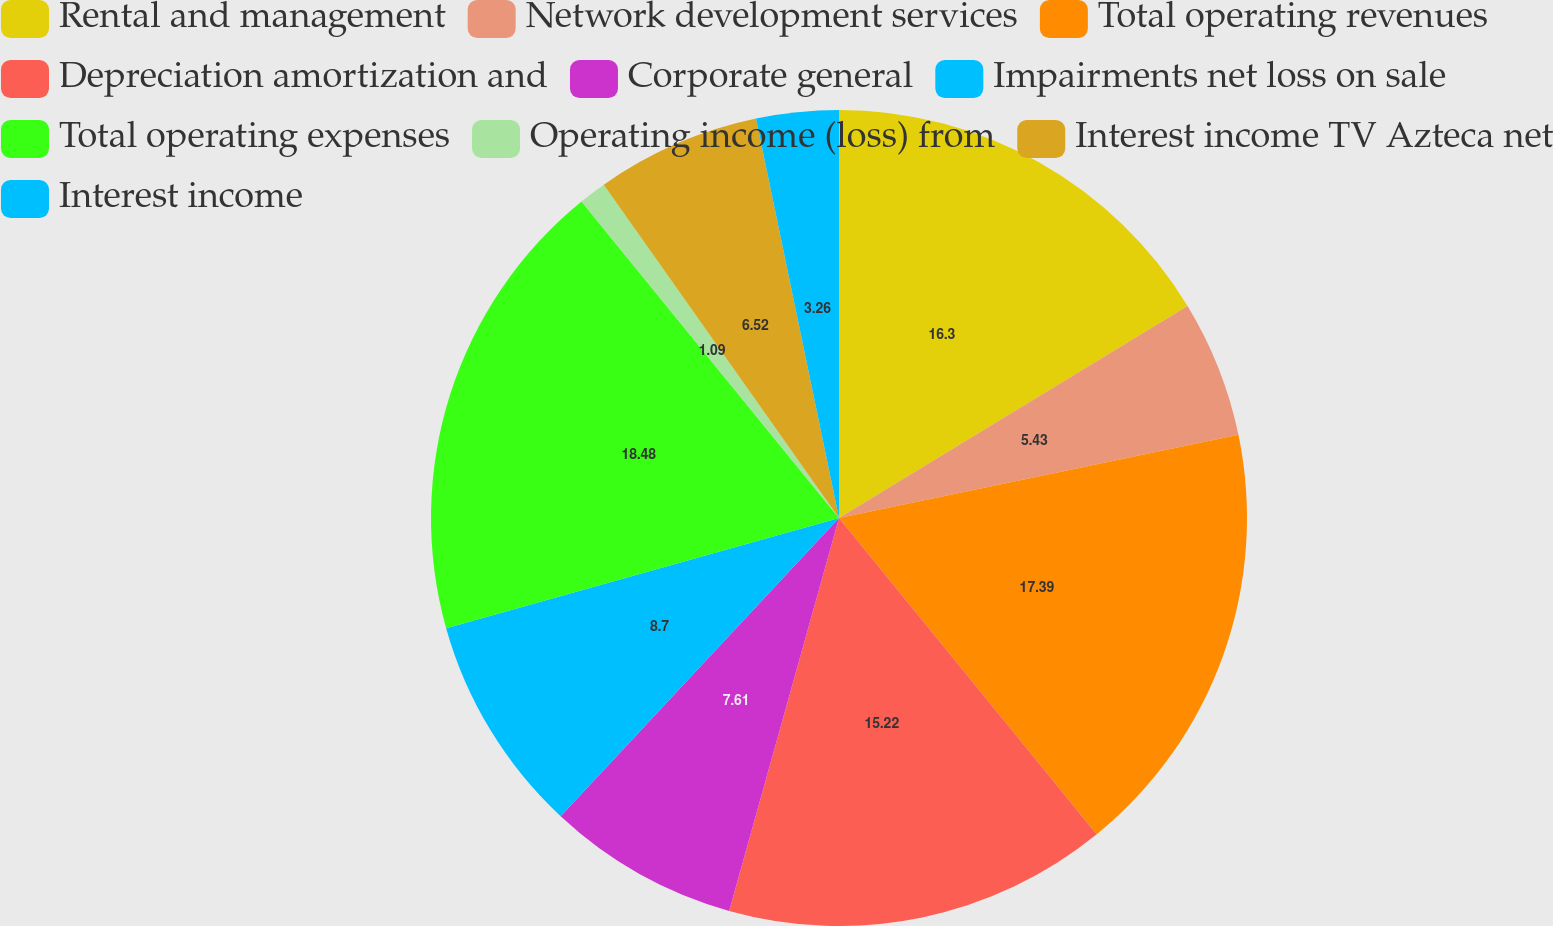<chart> <loc_0><loc_0><loc_500><loc_500><pie_chart><fcel>Rental and management<fcel>Network development services<fcel>Total operating revenues<fcel>Depreciation amortization and<fcel>Corporate general<fcel>Impairments net loss on sale<fcel>Total operating expenses<fcel>Operating income (loss) from<fcel>Interest income TV Azteca net<fcel>Interest income<nl><fcel>16.3%<fcel>5.43%<fcel>17.39%<fcel>15.22%<fcel>7.61%<fcel>8.7%<fcel>18.48%<fcel>1.09%<fcel>6.52%<fcel>3.26%<nl></chart> 